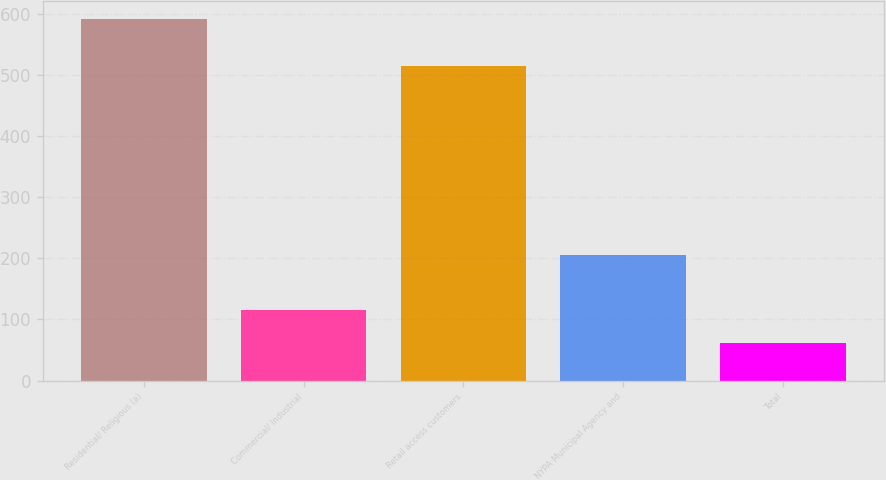Convert chart. <chart><loc_0><loc_0><loc_500><loc_500><bar_chart><fcel>Residential/ Religious (a)<fcel>Commercial/ Industrial<fcel>Retail access customers<fcel>NYPA Municipal Agency and<fcel>Total<nl><fcel>592<fcel>115<fcel>515<fcel>205<fcel>62<nl></chart> 